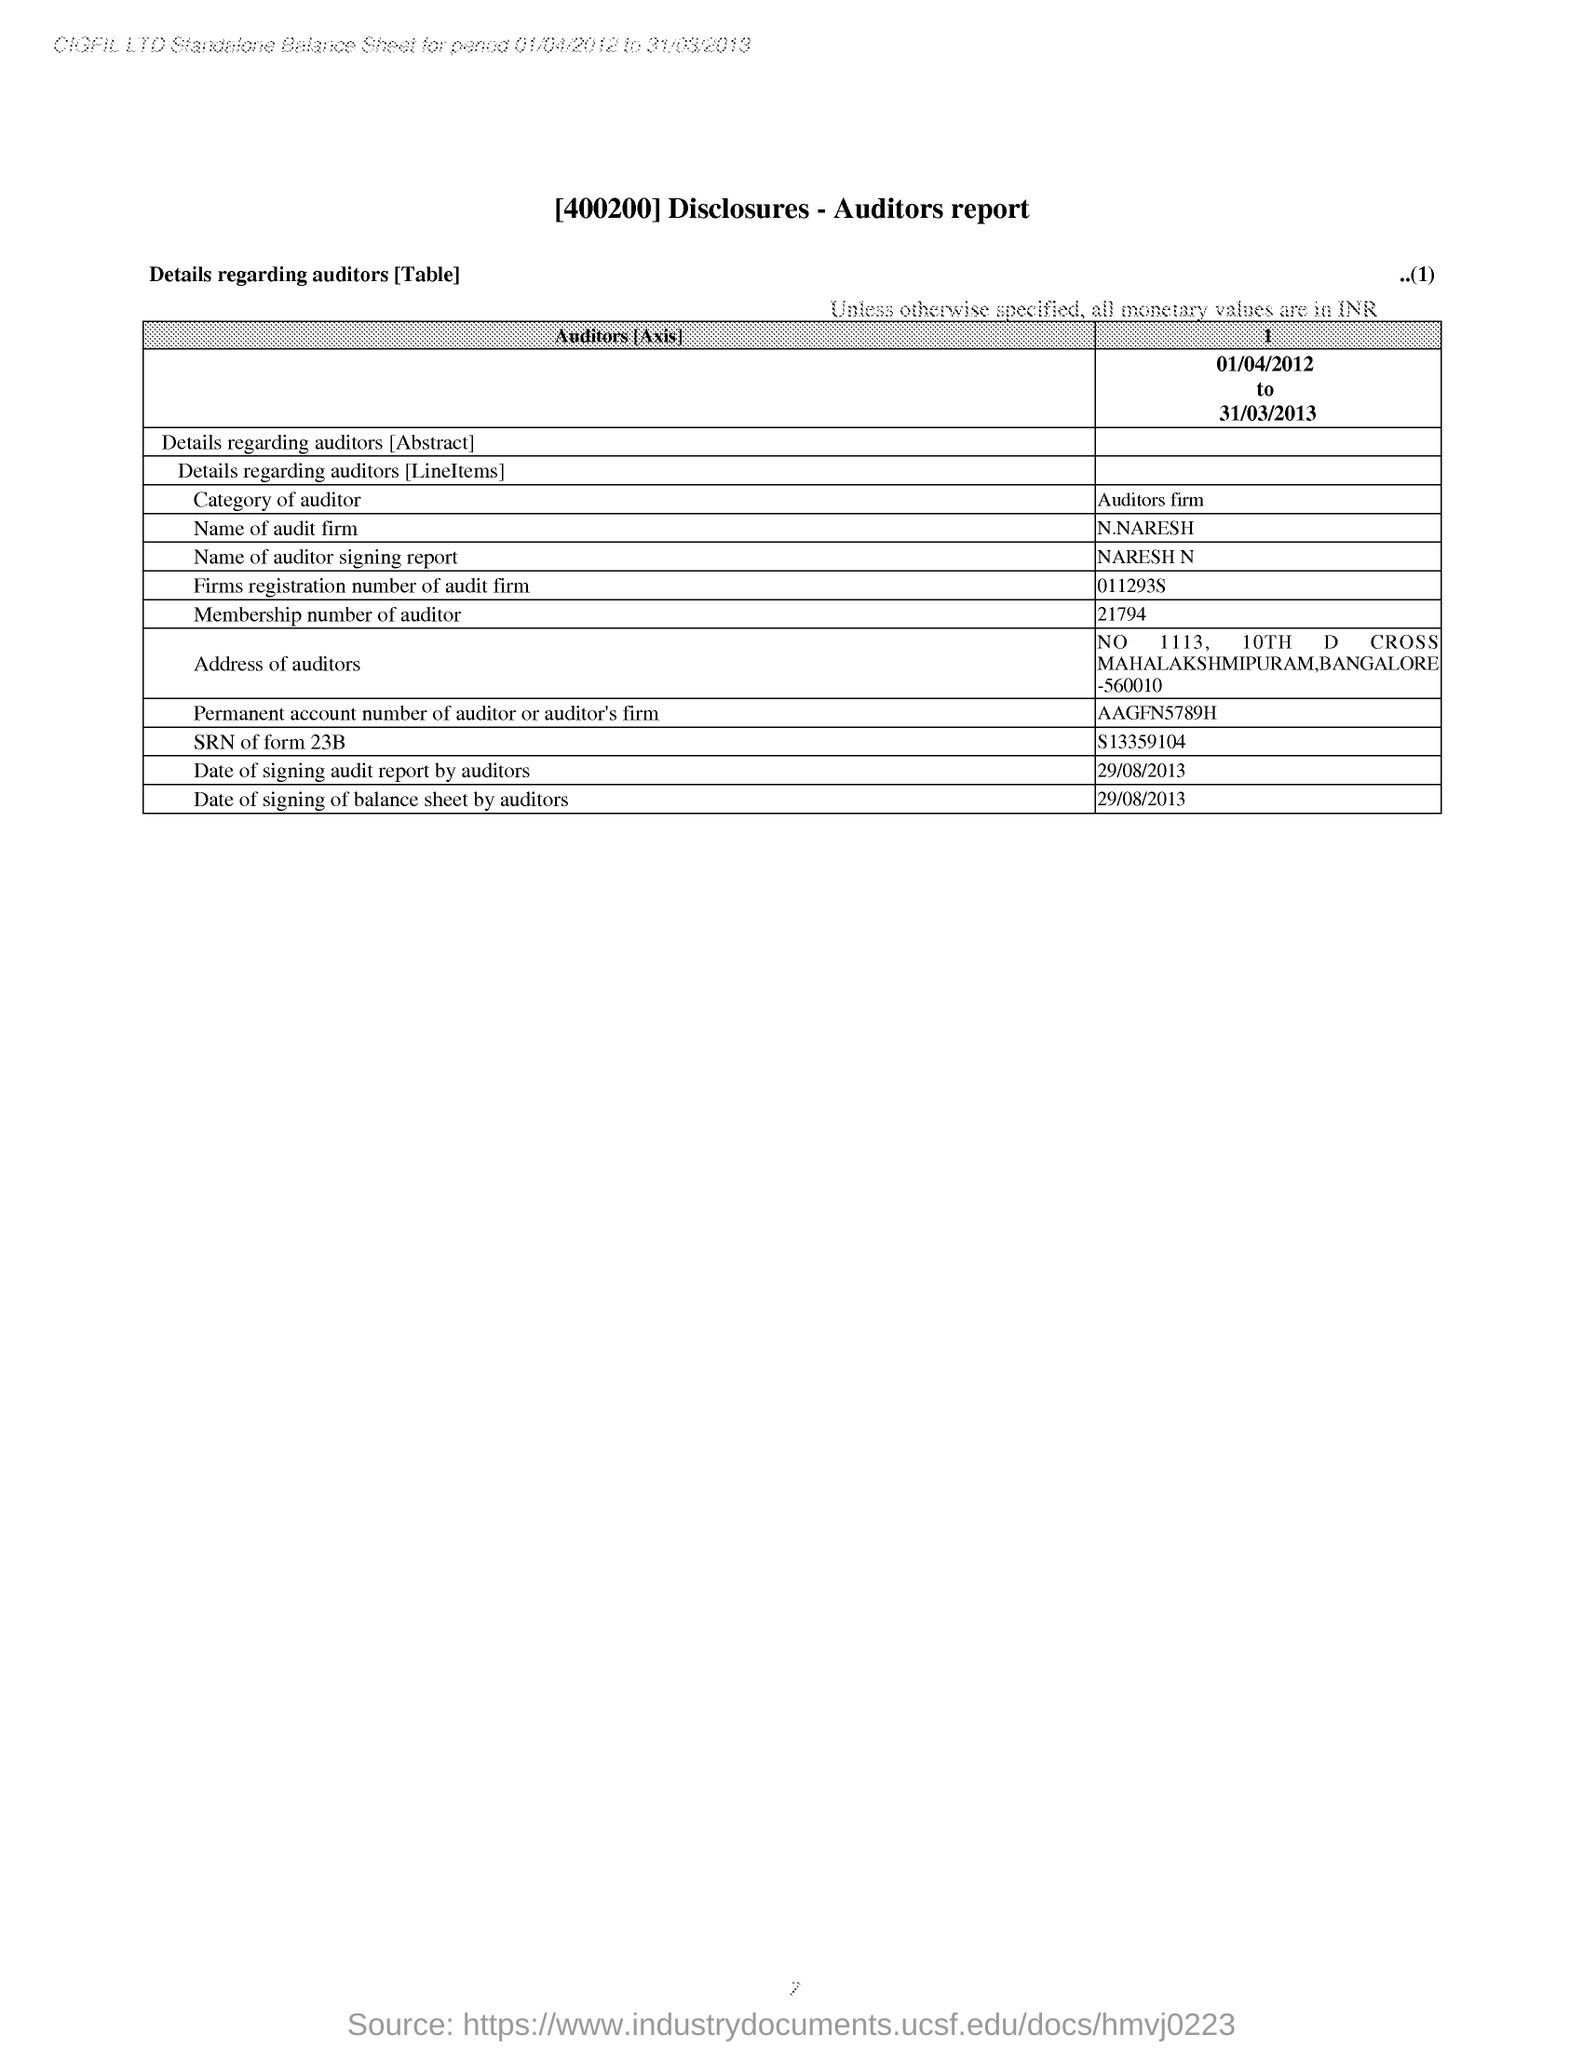Specify some key components in this picture. The category of the auditor mentioned in the report is an auditors firm. The document mentions a report called the auditor's report. The city mentioned in the address of the auditor is Bangalore. 